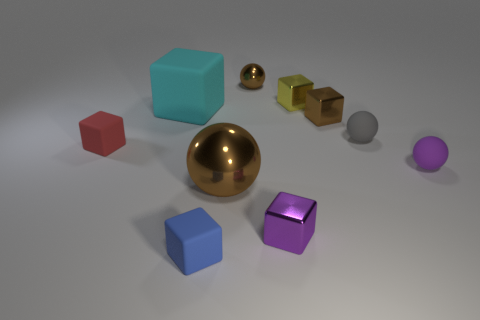Subtract 3 blocks. How many blocks are left? 3 Subtract all purple blocks. How many blocks are left? 5 Subtract all tiny brown metal cubes. How many cubes are left? 5 Subtract all cyan blocks. Subtract all yellow balls. How many blocks are left? 5 Subtract all cubes. How many objects are left? 4 Subtract 1 blue blocks. How many objects are left? 9 Subtract all large things. Subtract all big brown metallic spheres. How many objects are left? 7 Add 3 tiny brown balls. How many tiny brown balls are left? 4 Add 3 small green metallic blocks. How many small green metallic blocks exist? 3 